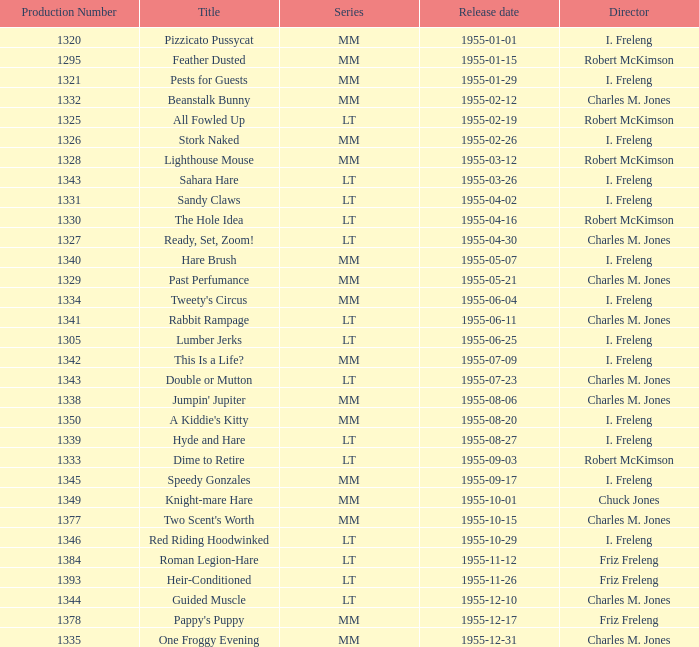What is the release date of production number 1327? 1955-04-30. 